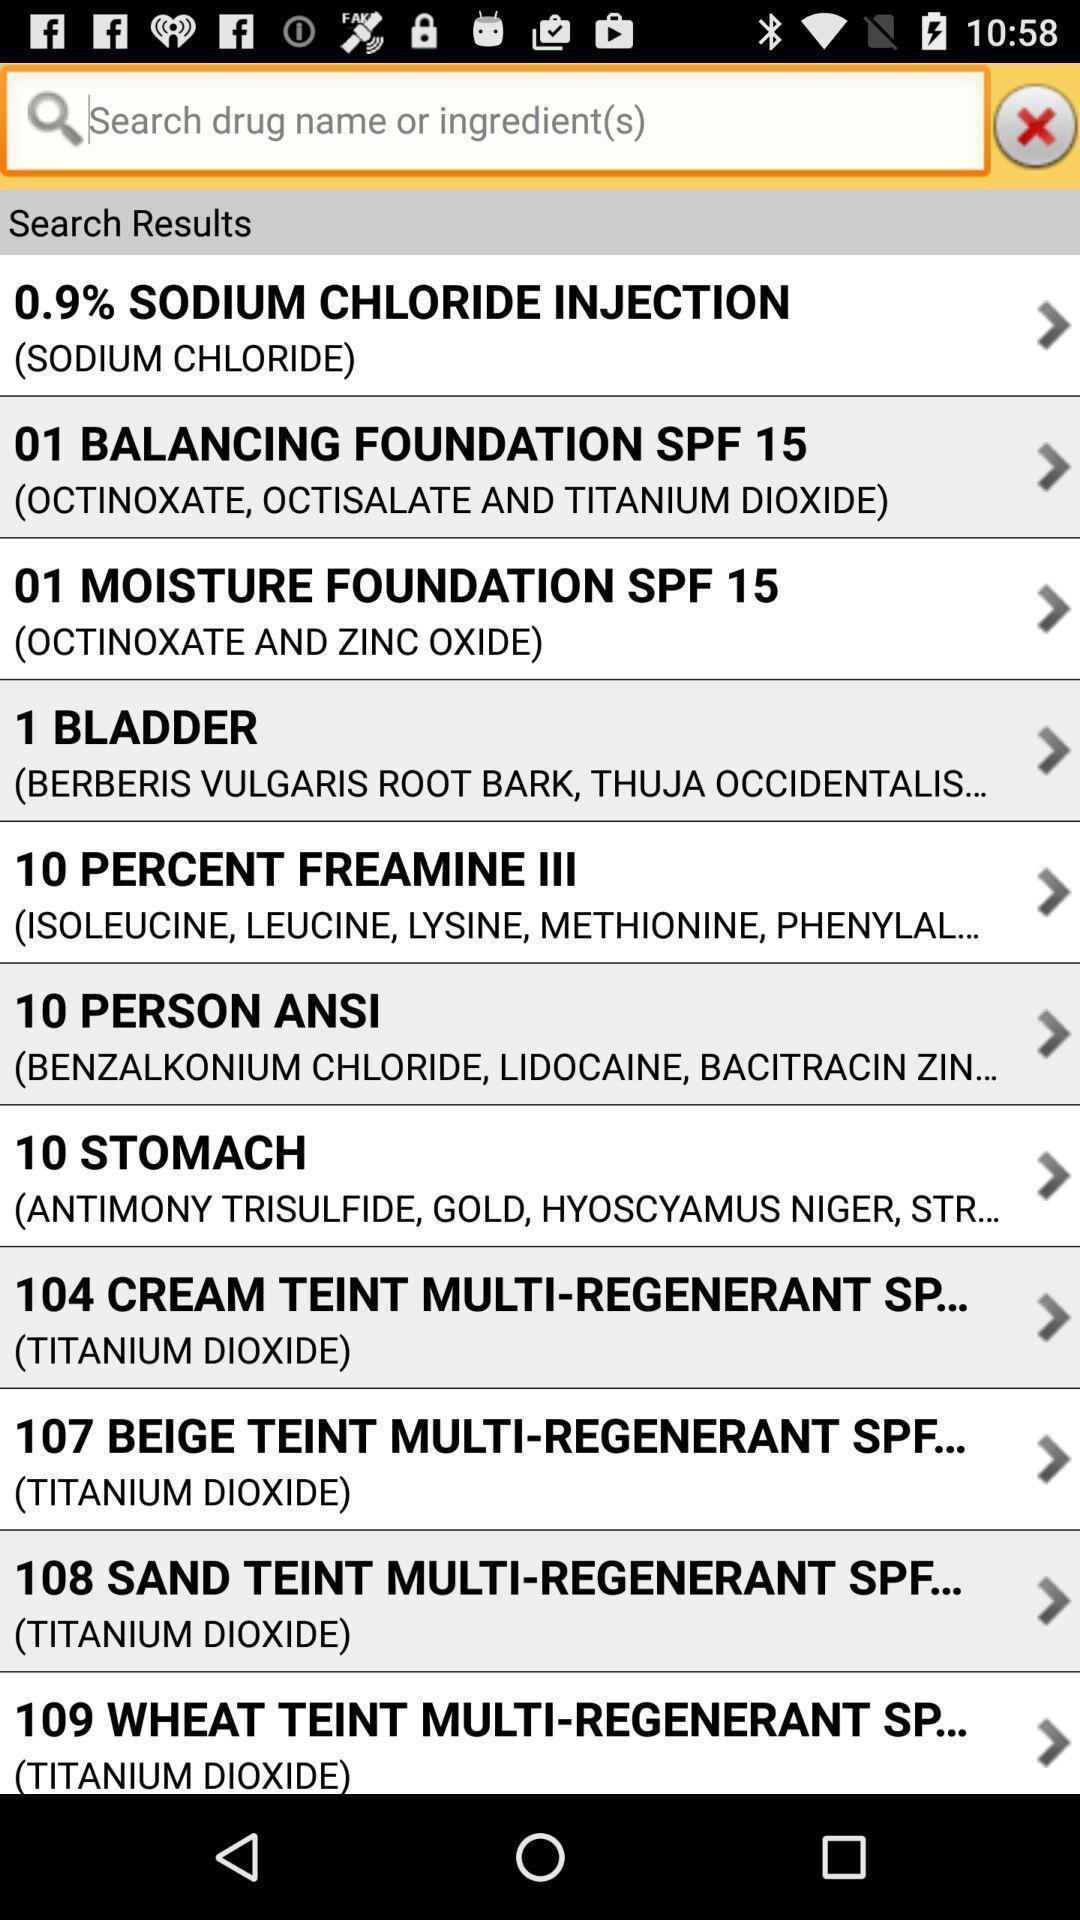What details can you identify in this image? Search page. 